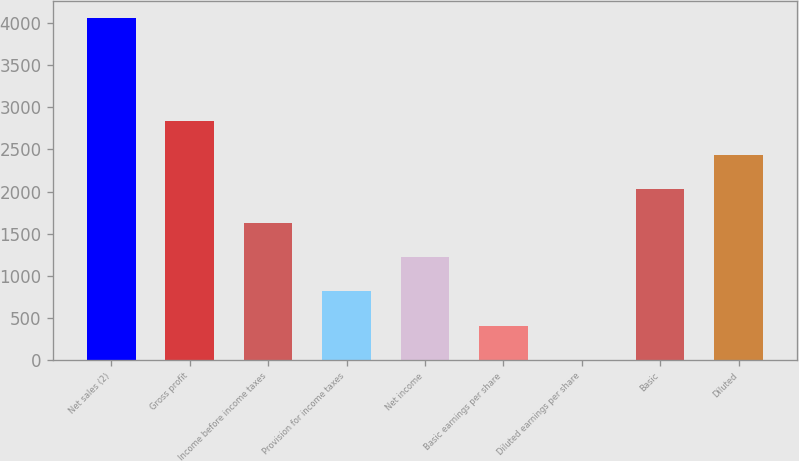Convert chart to OTSL. <chart><loc_0><loc_0><loc_500><loc_500><bar_chart><fcel>Net sales (2)<fcel>Gross profit<fcel>Income before income taxes<fcel>Provision for income taxes<fcel>Net income<fcel>Basic earnings per share<fcel>Diluted earnings per share<fcel>Basic<fcel>Diluted<nl><fcel>4063<fcel>2844.19<fcel>1625.41<fcel>812.89<fcel>1219.15<fcel>406.63<fcel>0.37<fcel>2031.67<fcel>2437.93<nl></chart> 